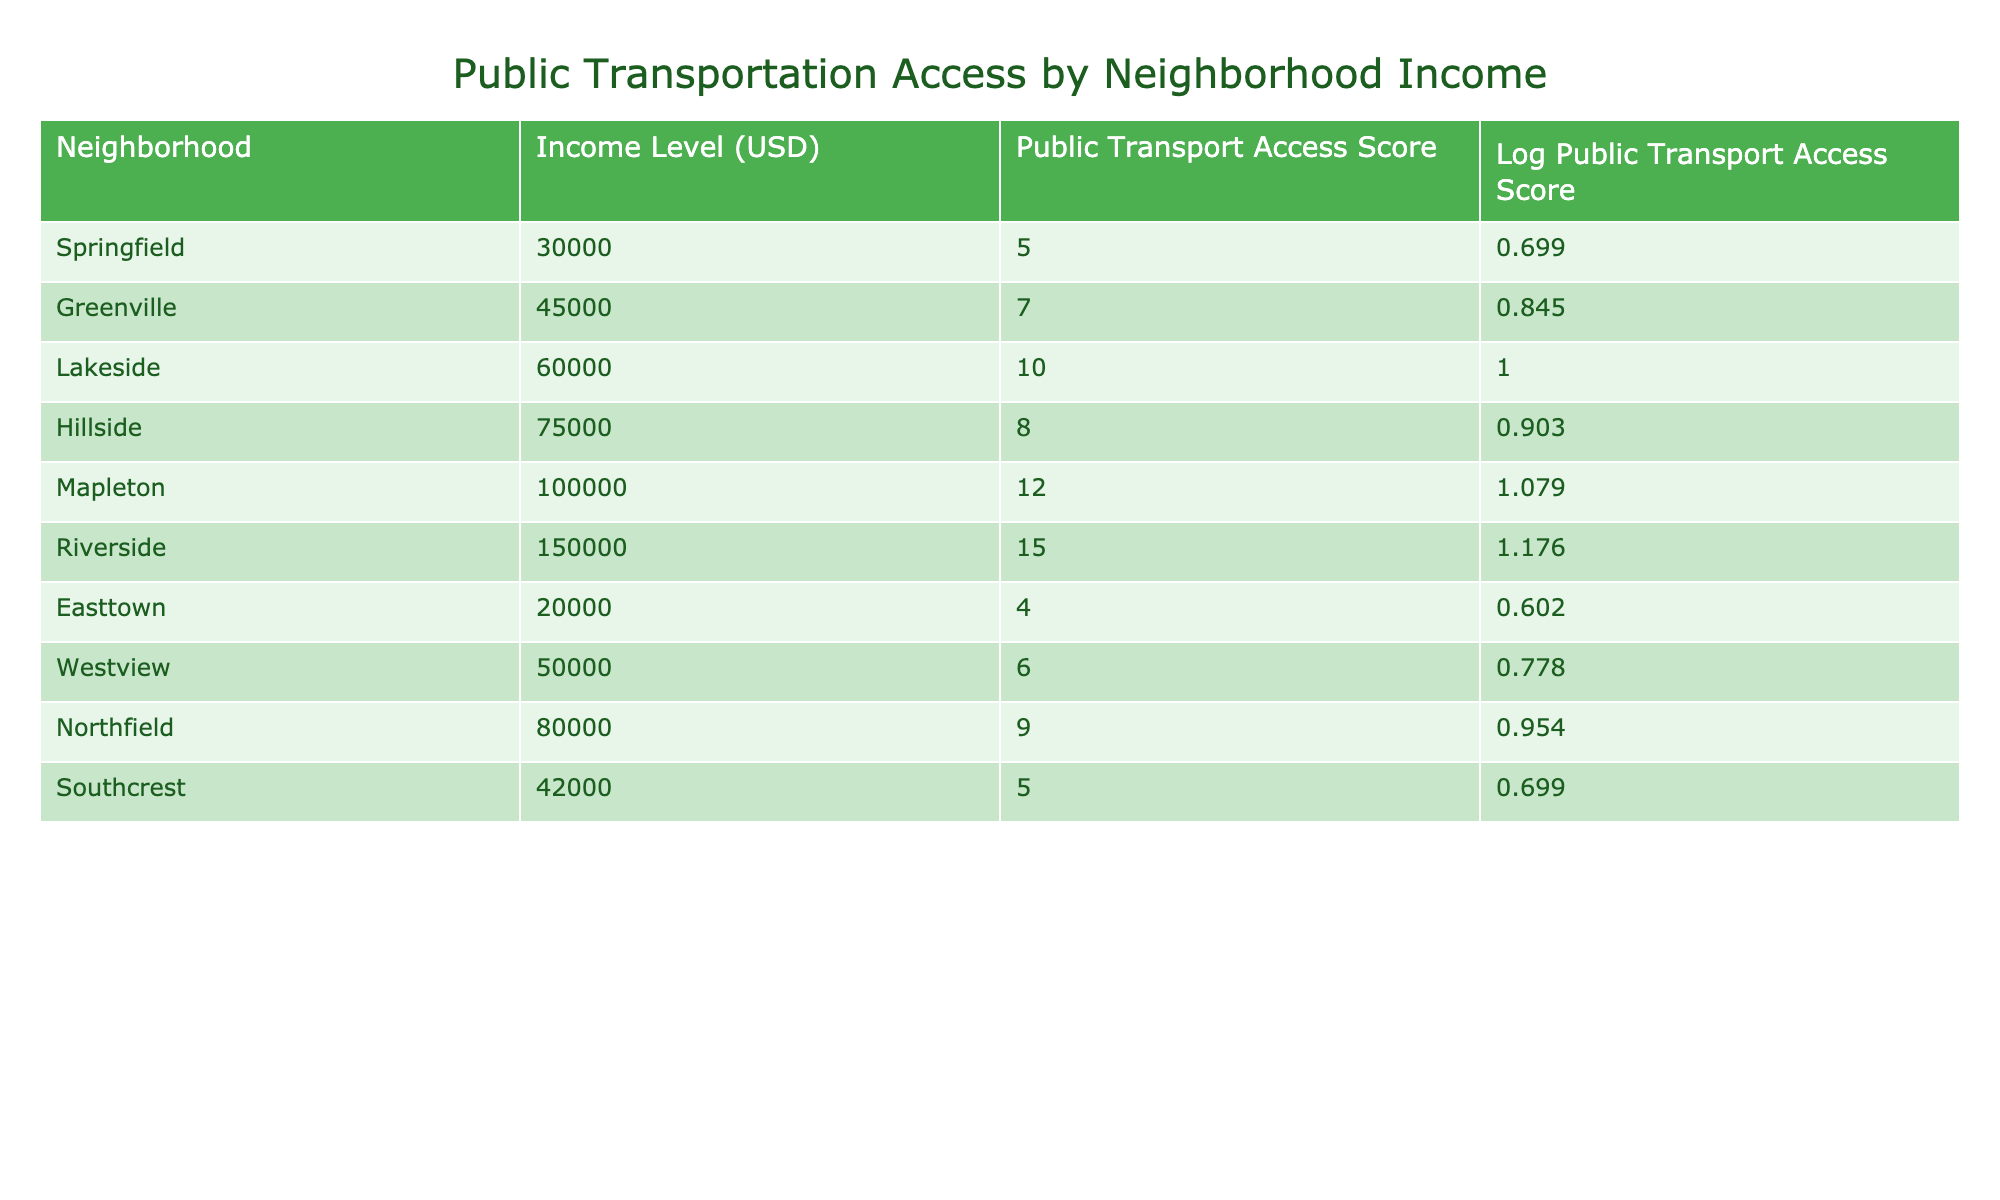What is the Public Transport Access Score for Lakeside? The table lists Lakeside under the neighborhood column with a Public Transport Access Score of 10, which is directly stated.
Answer: 10 Which neighborhood has the highest Public Transport Access Score? By examining the Public Transport Access Score column, Riverside has the highest score of 15.
Answer: Riverside What is the difference in Public Transport Access Scores between Riverside and Easttown? Riverside has a score of 15 and Easttown has a score of 4. The difference is found by calculating 15 - 4 = 11.
Answer: 11 Is the average Public Transport Access Score for income levels below 50,000 higher than for income levels above 50,000? Calculate the scores for neighborhoods with income below 50,000: Easttown (4), Southcrest (5), Springfield (5), Greenville (7), and Westview (6). The average is (4 + 5 + 5 + 7 + 6) / 5 = 5.4. For above 50,000, the scores are: Lakeside (10), Hillside (8), Mapleton (12), Riverside (15), Northfield (9). Average is (10 + 8 + 12 + 15 + 9) / 5 = 10.8. Comparing 5.4 and 10.8, the latter is higher.
Answer: No What is the total Public Transport Access Score for neighborhoods with income levels between 40,000 and 80,000? The neighborhoods in this income range are Greenville (7), Hillside (8), Southcrest (5), Westview (6), and Northfield (9). The total score is calculated as: 7 + 8 + 5 + 6 + 9 = 35.
Answer: 35 Does any neighborhood with an income level of 100,000 or more have a Public Transport Access Score below 12? The only neighborhood in this income range is Mapleton (12) and Riverside (15). Both scores are not below 12, so the answer is no.
Answer: No What is the median Public Transport Access Score for all neighborhoods listed? To find the median, arrange all scores: 4, 5, 5, 6, 7, 8, 9, 10, 12, 15. The middle values are 7 and 8 (since there are 10 values), so the median is (7 + 8) / 2 = 7.5.
Answer: 7.5 Which income level has the most neighborhoods with a Public Transport Access Score of 5 or lower? The neighborhoods with a score of 5 or lower are Easttown (4), Springfield (5), and Southcrest (5), which all fall under income levels of 20,000 and 30,000. Hence, these levels have the most neighborhoods meeting this criterion.
Answer: 20,000 What is the logarithmic value of the Public Transport Access Score for the neighborhood with the lowest income level? Easttown is the neighborhood with the lowest income level of 20,000, which has a Log Public Transport Access Score of 0.602.
Answer: 0.602 